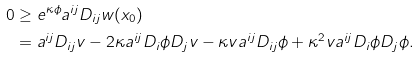<formula> <loc_0><loc_0><loc_500><loc_500>0 & \geq e ^ { \kappa \phi } a ^ { i j } D _ { i j } w ( x _ { 0 } ) \\ & = a ^ { i j } D _ { i j } v - 2 \kappa a ^ { i j } D _ { i } \phi D _ { j } v - \kappa v a ^ { i j } D _ { i j } \phi + \kappa ^ { 2 } v a ^ { i j } D _ { i } \phi D _ { j } \phi .</formula> 